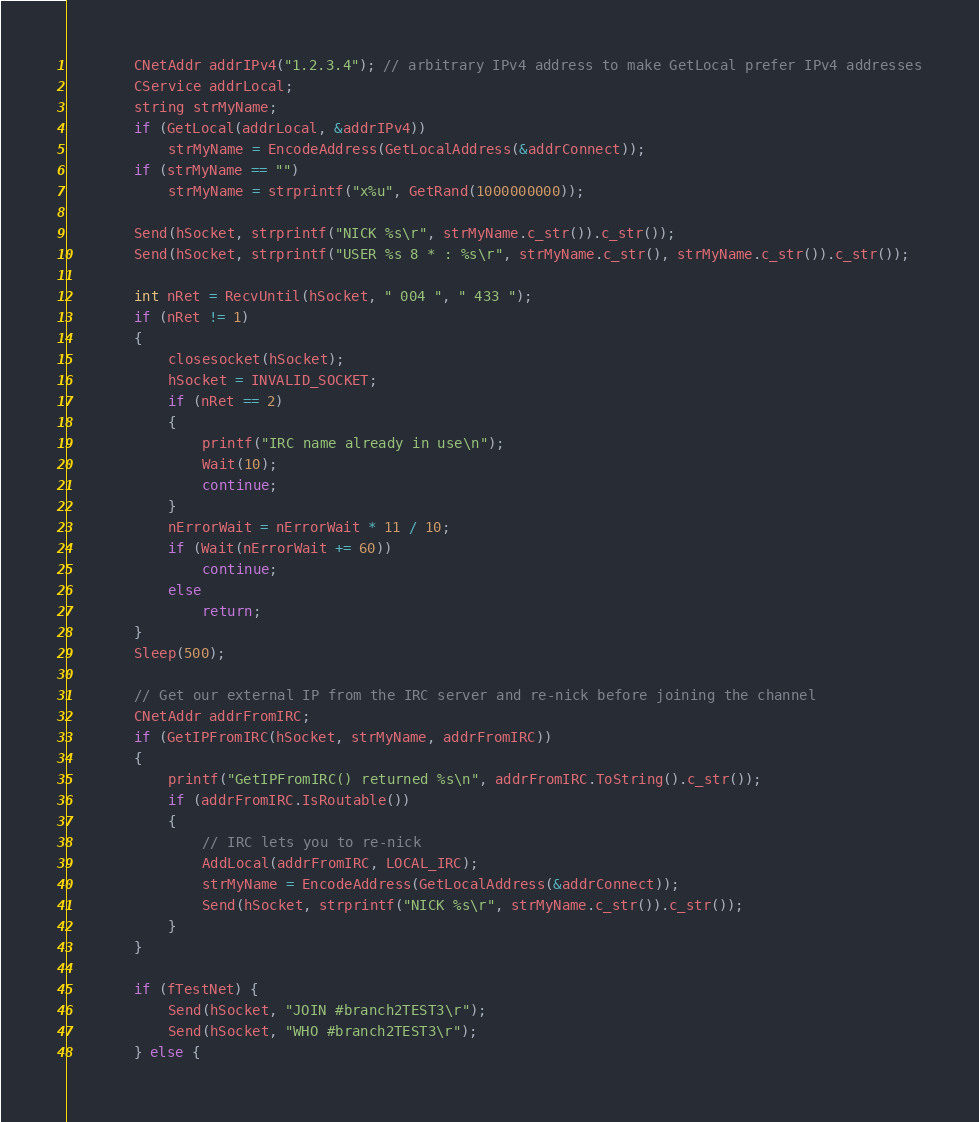<code> <loc_0><loc_0><loc_500><loc_500><_C++_>        CNetAddr addrIPv4("1.2.3.4"); // arbitrary IPv4 address to make GetLocal prefer IPv4 addresses
        CService addrLocal;
        string strMyName;
        if (GetLocal(addrLocal, &addrIPv4))
            strMyName = EncodeAddress(GetLocalAddress(&addrConnect));
        if (strMyName == "")
            strMyName = strprintf("x%u", GetRand(1000000000));

        Send(hSocket, strprintf("NICK %s\r", strMyName.c_str()).c_str());
        Send(hSocket, strprintf("USER %s 8 * : %s\r", strMyName.c_str(), strMyName.c_str()).c_str());

        int nRet = RecvUntil(hSocket, " 004 ", " 433 ");
        if (nRet != 1)
        {
            closesocket(hSocket);
            hSocket = INVALID_SOCKET;
            if (nRet == 2)
            {
                printf("IRC name already in use\n");
                Wait(10);
                continue;
            }
            nErrorWait = nErrorWait * 11 / 10;
            if (Wait(nErrorWait += 60))
                continue;
            else
                return;
        }
        Sleep(500);

        // Get our external IP from the IRC server and re-nick before joining the channel
        CNetAddr addrFromIRC;
        if (GetIPFromIRC(hSocket, strMyName, addrFromIRC))
        {
            printf("GetIPFromIRC() returned %s\n", addrFromIRC.ToString().c_str());
            if (addrFromIRC.IsRoutable())
            {
                // IRC lets you to re-nick
                AddLocal(addrFromIRC, LOCAL_IRC);
                strMyName = EncodeAddress(GetLocalAddress(&addrConnect));
                Send(hSocket, strprintf("NICK %s\r", strMyName.c_str()).c_str());
            }
        }
        
        if (fTestNet) {
            Send(hSocket, "JOIN #branch2TEST3\r");
            Send(hSocket, "WHO #branch2TEST3\r");
        } else {</code> 